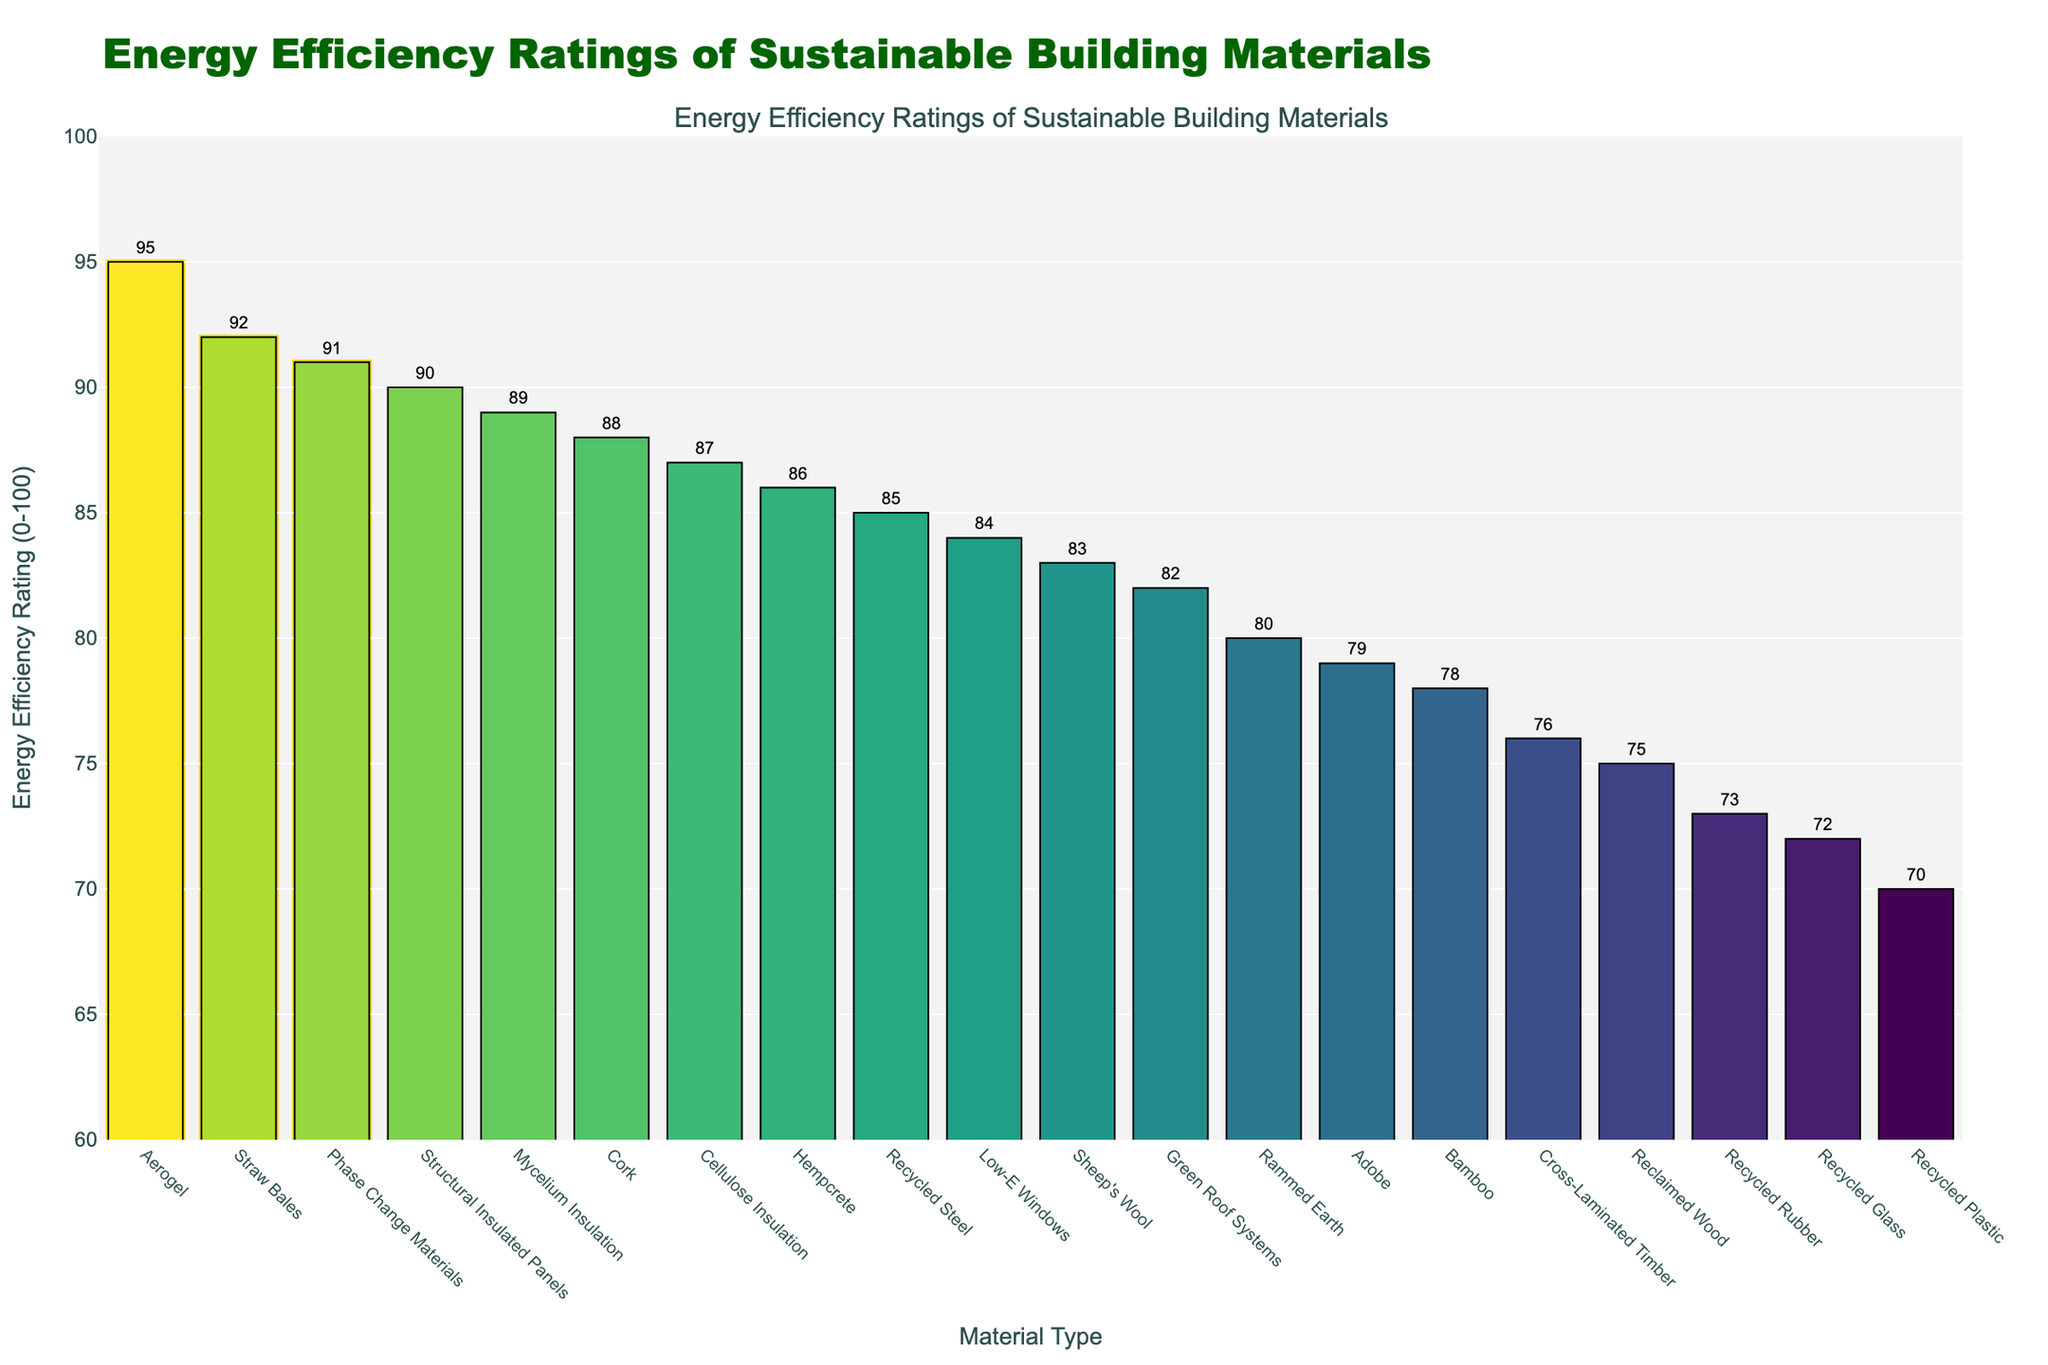Which material type has the highest energy efficiency rating? Inspect the figure and identify the bar that reaches the highest point. This bar represents the material with the highest rating.
Answer: Aerogel How much higher is the energy efficiency rating of Straw Bales compared to Recycled Plastic? Locate the bars for Straw Bales (92) and Recycled Plastic (70). Subtract the lower value from the higher value to find the difference: 92 - 70 = 22.
Answer: 22 What is the average energy efficiency rating of the top three materials? Identify the top three bars: Aerogel (95), Phase Change Materials (91), and Straw Bales (92). Calculate the average: (95 + 91 + 92)/3 = 278/3 = 92.67.
Answer: 92.67 Which material type is visually represented with a color close to the green spectrum and a rating above 85? Identify bars colored near green in the Viridis scale and with heights representing ratings above 85, like Mycelium Insulation (89), Cellulose Insulation (87), and Cork (88).
Answer: Mycelium Insulation, Cork, Cellulose Insulation Is Cross-Laminated Timber more energy efficient than Recycled Plastic? Compare the heights of bars for Cross-Laminated Timber (76) and Recycled Plastic (70). Since 76 is greater than 70, Cross-Laminated Timber is more efficient.
Answer: Yes What is the combined energy efficiency rating of materials that start with the letter "R"? Identify the materials: Recycled Steel (85), Recycled Plastic (70), Rammed Earth (80), Reclaimed Wood (75), Recycled Glass (72), Recycled Rubber (73). Add their ratings: 85 + 70 + 80 + 75 + 72 + 73 = 455.
Answer: 455 Which material has the closest energy efficiency rating to the mean rating of all materials? First, calculate the mean rating of all 20 materials (total sum = 1678, mean = 1678/20 = 83.9). The closest rating to 83.9 in the list are Sheep's Wool (83).
Answer: Sheep's Wool Compare the efficiency rating of Mycelium Insulation with that of Green Roof Systems. Which one is higher and by how much? Check the ratings for Mycelium Insulation (89) and Green Roof Systems (82). Subtract the lower from the higher: 89 - 82 = 7.
Answer: Mycelium Insulation, 7 How many materials have an energy efficiency rating above 85? Count the number of bars representing a rating above 85. These materials are Aerogel, Phase Change Materials, Straw Bales, Structural Insulated Panels, Mycelium Insulation, Hempcrete, Cellulose Insulation, Cork. There are 8 such materials.
Answer: 8 Which three materials have the lowest energy efficiency ratings, and what are those ratings? Identify the bars with the lowest heights and their corresponding labels: Recycled Plastic (70), Recycled Glass (72), Recycled Rubber (73).
Answer: Recycled Plastic (70), Recycled Glass (72), Recycled Rubber (73) 